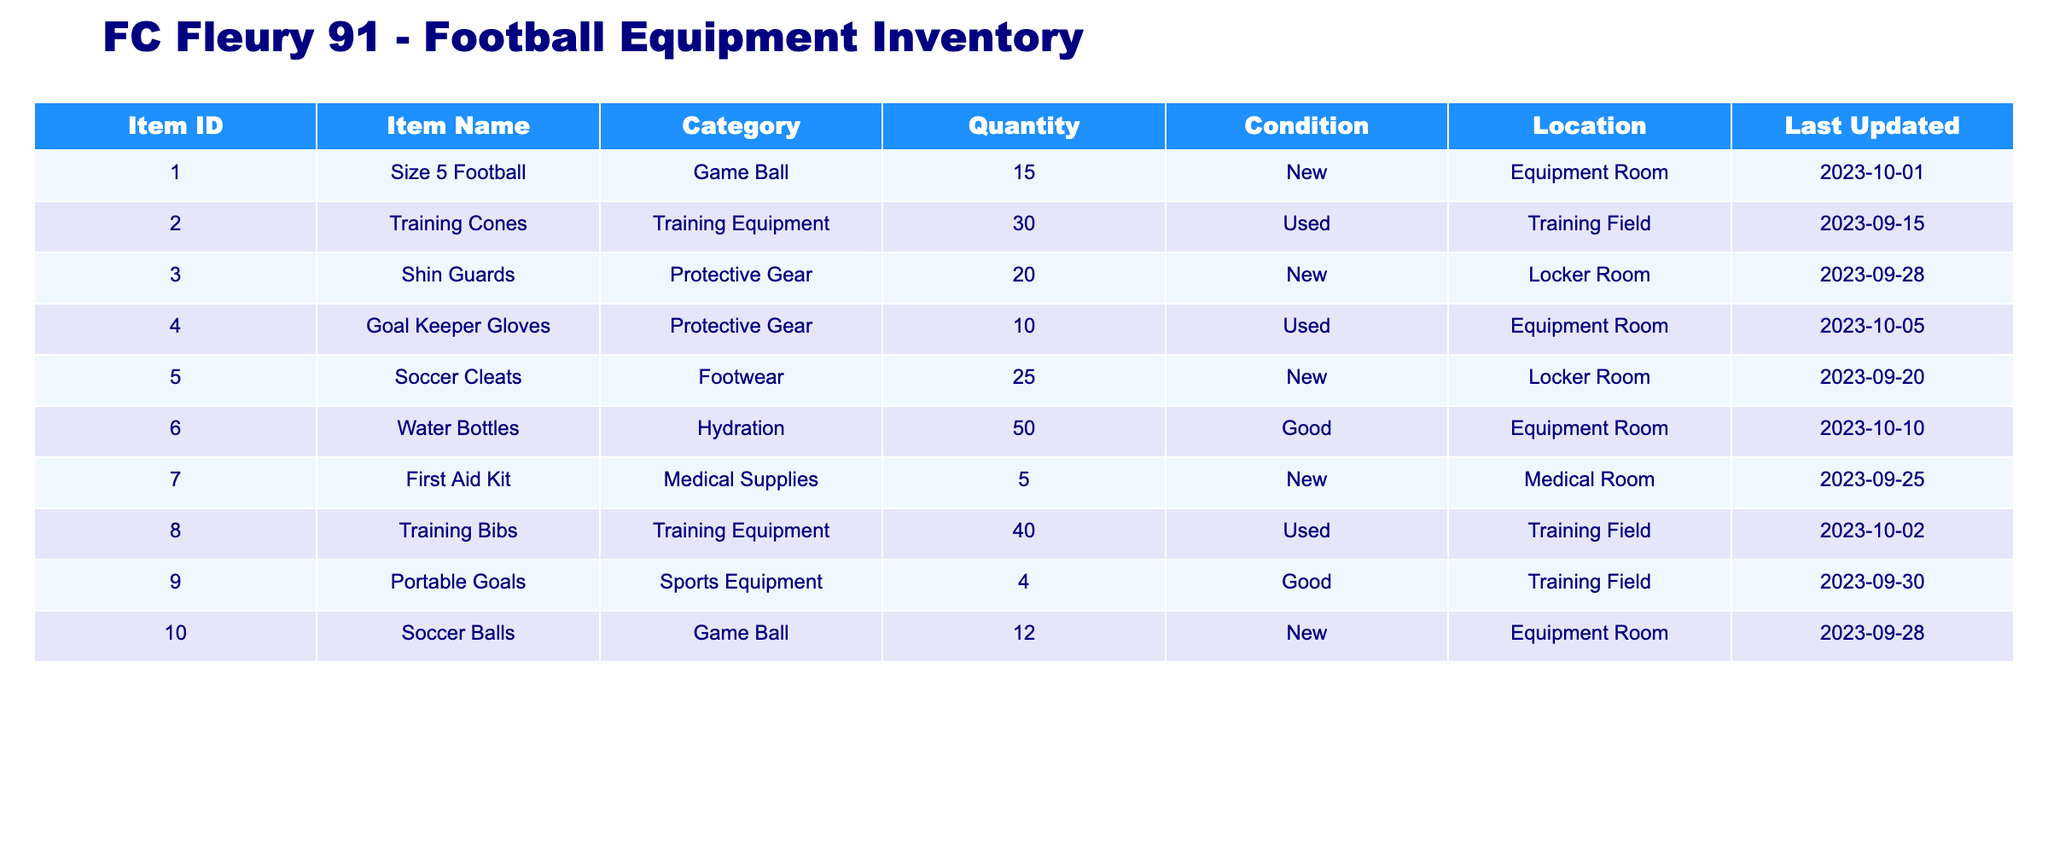What is the total quantity of Game Balls in the inventory? There are two items in the Game Ball category: Size 5 Football with a quantity of 15 and Soccer Balls with a quantity of 12. Adding these gives us 15 + 12 = 27.
Answer: 27 How many Training Equipment items are in good or new condition? The Training Equipment category includes Training Cones, which are used (30), and Training Bibs, which are used (40). There are no items listed as new, so the total in good or new condition is 0.
Answer: 0 Is there a First Aid Kit available in the inventory? The table shows that there are 5 First Aid Kits listed in the Medical Supplies category, indicating their availability.
Answer: Yes What is the total number of Protective Gear items? There are 20 Shin Guards and 10 Goal Keeper Gloves in the inventory. Adding these gives us 20 + 10 = 30 Protective Gear items in total.
Answer: 30 How many items in the Equipment Room are classified as New? The Equipment Room contains Size 5 Football (15) and Soccer Balls (12) classified as New, while Goal Keeper Gloves (10) are used. Adding the New items gives 15 + 12 = 27 items total that are classified as New in the Equipment Room.
Answer: 27 Are there more Soccer Cleats than Shin Guards in the inventory? The Quantity of Soccer Cleats is 25, while Shin Guards stand at 20. Since 25 is greater than 20, we can confirm that there are more Soccer Cleats than Shin Guards.
Answer: Yes What is the average quantity of Hydration items? There is one item under Hydration, which is Water Bottles with a quantity of 50. The average is simply 50/1 = 50, as there is only one item to consider.
Answer: 50 How many more Training Equipment items are there compared to Protective Gear? There are a total of 30 Training Equipment items (30 Training Cones + 40 Training Bibs) and 30 Protective Gear items. To find the difference, we calculate 30 - 30, which equals 0.
Answer: 0 Which location has the highest quantity of items? To find the location with the highest quantity, we compare the quantities: Equipment Room (27), Training Field (70), Locker Room (25), and Medical Room (5). The Training Field has the highest total of 70 items.
Answer: Training Field 